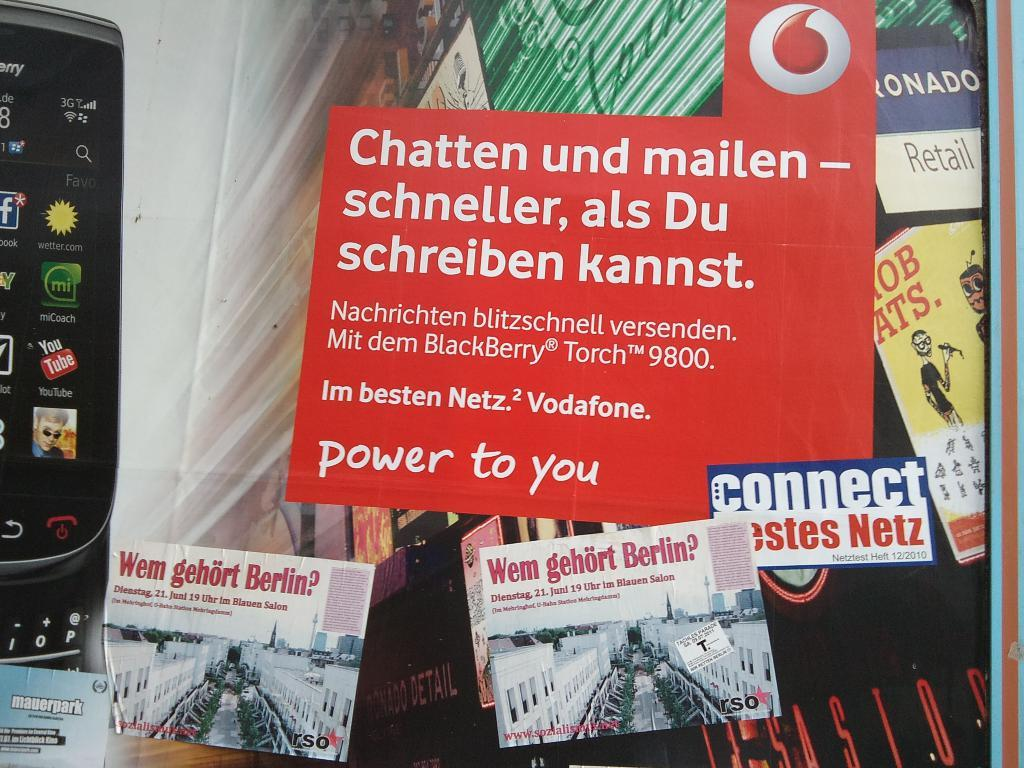<image>
Provide a brief description of the given image. A collection of postcards with one titled Chatten und mailen. 